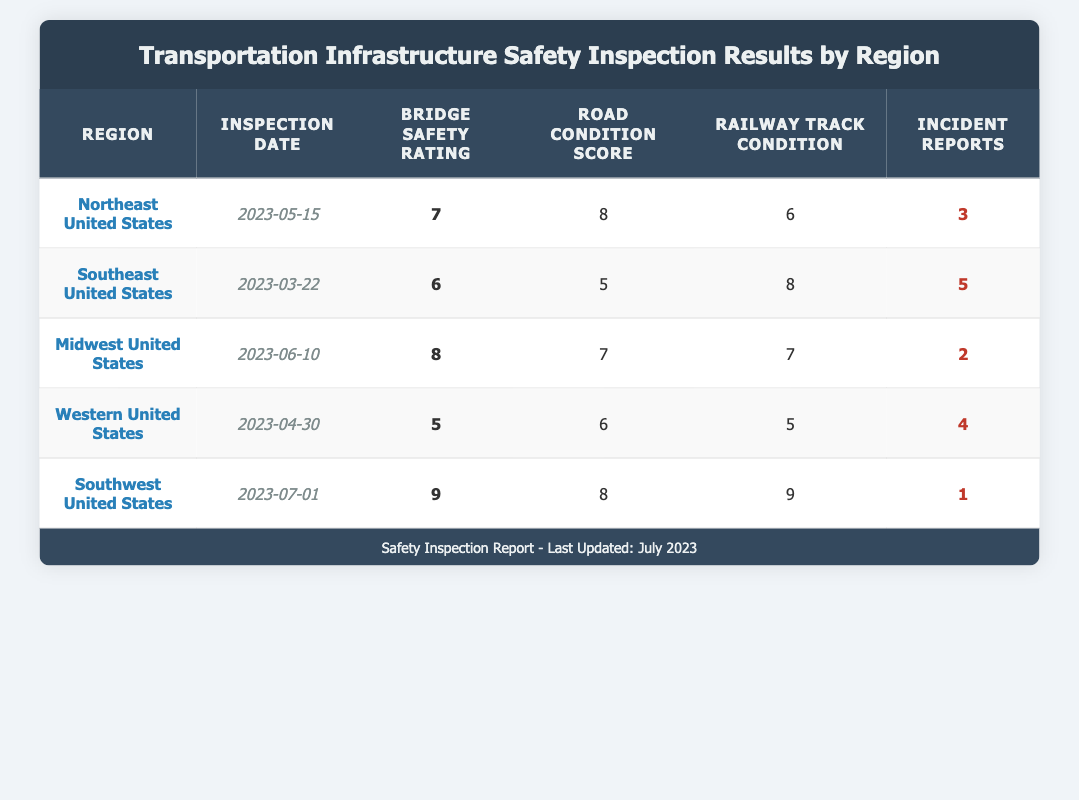What is the highest Bridge Safety Rating among all regions? By checking the Bridge Safety Rating column, I can see that the highest rating is 9, which corresponds to the Southwest United States.
Answer: 9 Which region has the lowest Road Condition Score? The Road Condition Score column shows scores of 8, 5, 7, 6, and 8. The lowest score is 5, which belongs to the Southeast United States.
Answer: Southeast United States How many Incident Reports were recorded in total across all regions? By adding the Incident Reports from each region: 3 + 5 + 2 + 4 + 1 = 15. Therefore, the total number of Incident Reports is 15.
Answer: 15 Which region has the best overall safety ratings across all categories (Bridge Safety, Road Condition, Railway Track)? To determine this, I can analyze each region's ratings: Northeast (7, 8, 6), Southeast (6, 5, 8), Midwest (8, 7, 7), Western (5, 6, 5), Southwest (9, 8, 9). Adding each region's ratings gives Midwest a total of 22 and Southwest a total of 26. The Southwest United States has the best ratings overall with a total of 26.
Answer: Southwest United States Is it true that the Western United States has more Incident Reports than the Midwest United States? The Incident Reports for Western United States is 4, while for Midwest United States it is 2. Therefore, it is true that the Western United States has more Incident Reports.
Answer: Yes What is the average Railway Track Condition across all regions? The Railway Track Condition scores are 6, 8, 7, 5, and 9. First, I add these scores: 6 + 8 + 7 + 5 + 9 = 35. Then, divide by the number of regions (5) to get the average: 35 / 5 = 7.
Answer: 7 Which region experienced the least number of Incident Reports? Looking at the Incident Reports, the values are 3, 5, 2, 4, and 1. The smallest number of Incident Reports is 1, which belongs to the Southwest United States.
Answer: Southwest United States Does the Midwest United States have a higher Bridge Safety Rating compared to the Southeast United States? The Bridge Safety Ratings are 8 for the Midwest and 6 for the Southeast. Since 8 is greater than 6, it is true that the Midwest United States has a higher Bridge Safety Rating.
Answer: Yes 